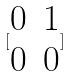<formula> <loc_0><loc_0><loc_500><loc_500>[ \begin{matrix} 0 & 1 \\ 0 & 0 \end{matrix} ]</formula> 